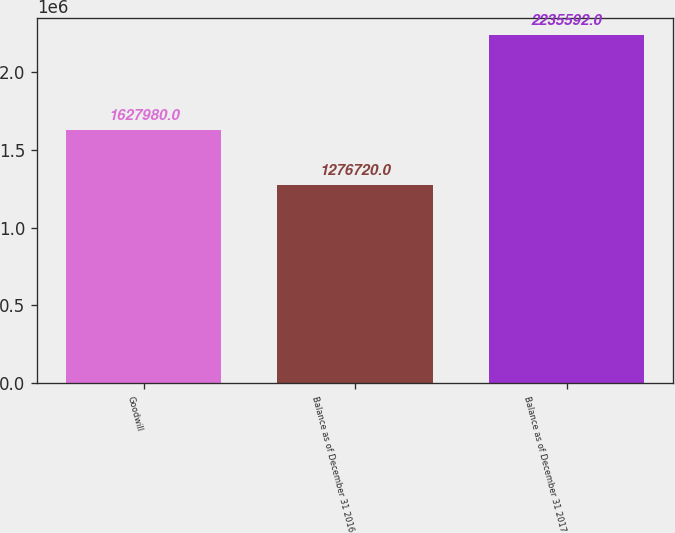<chart> <loc_0><loc_0><loc_500><loc_500><bar_chart><fcel>Goodwill<fcel>Balance as of December 31 2016<fcel>Balance as of December 31 2017<nl><fcel>1.62798e+06<fcel>1.27672e+06<fcel>2.23559e+06<nl></chart> 